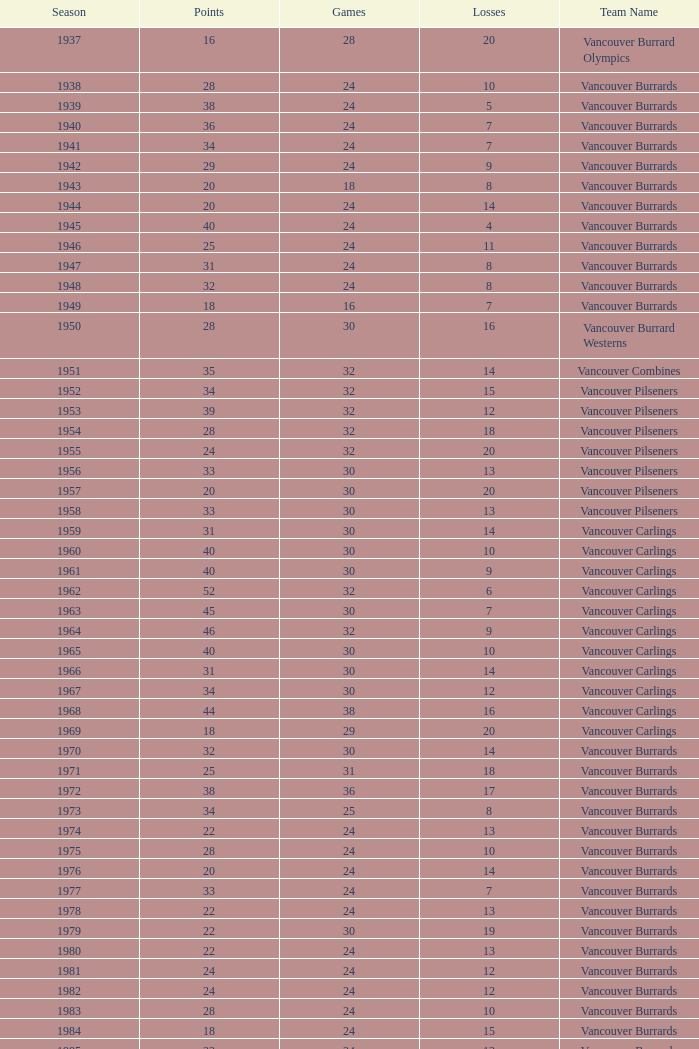What's the lowest number of points with fewer than 8 losses and fewer than 24 games for the vancouver burrards? 18.0. 